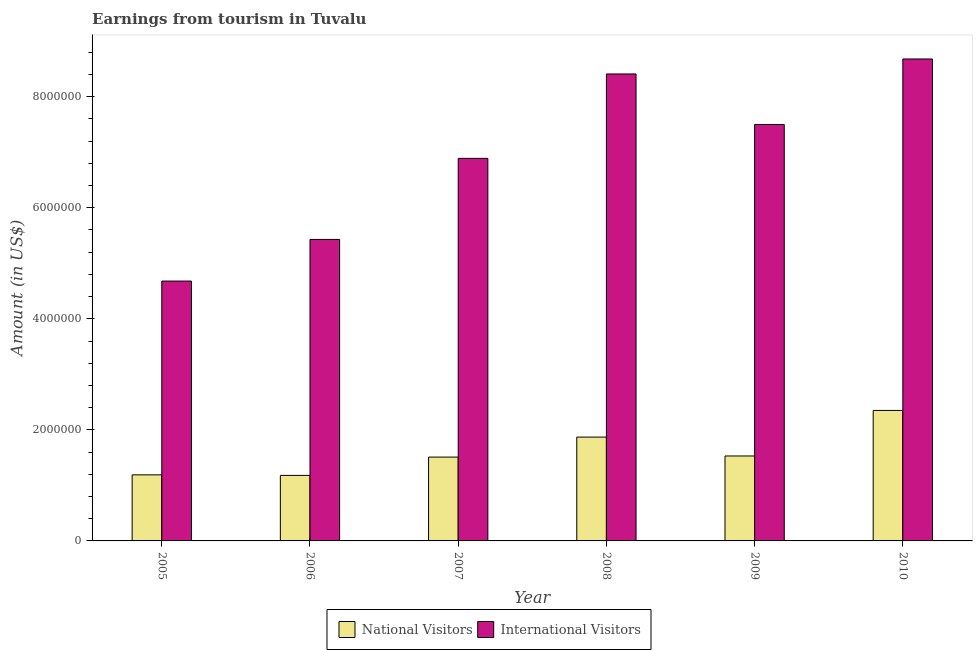Are the number of bars on each tick of the X-axis equal?
Make the answer very short. Yes. How many bars are there on the 6th tick from the left?
Provide a short and direct response. 2. What is the label of the 1st group of bars from the left?
Your answer should be compact. 2005. In how many cases, is the number of bars for a given year not equal to the number of legend labels?
Give a very brief answer. 0. What is the amount earned from national visitors in 2008?
Give a very brief answer. 1.87e+06. Across all years, what is the maximum amount earned from national visitors?
Your answer should be compact. 2.35e+06. Across all years, what is the minimum amount earned from international visitors?
Offer a terse response. 4.68e+06. In which year was the amount earned from international visitors minimum?
Offer a terse response. 2005. What is the total amount earned from national visitors in the graph?
Offer a terse response. 9.63e+06. What is the difference between the amount earned from international visitors in 2005 and that in 2010?
Offer a terse response. -4.00e+06. What is the difference between the amount earned from international visitors in 2008 and the amount earned from national visitors in 2007?
Your answer should be very brief. 1.52e+06. What is the average amount earned from national visitors per year?
Ensure brevity in your answer.  1.60e+06. In the year 2006, what is the difference between the amount earned from national visitors and amount earned from international visitors?
Make the answer very short. 0. In how many years, is the amount earned from national visitors greater than 800000 US$?
Keep it short and to the point. 6. What is the ratio of the amount earned from international visitors in 2005 to that in 2008?
Offer a terse response. 0.56. Is the difference between the amount earned from international visitors in 2008 and 2009 greater than the difference between the amount earned from national visitors in 2008 and 2009?
Keep it short and to the point. No. What is the difference between the highest and the second highest amount earned from international visitors?
Your answer should be compact. 2.70e+05. What is the difference between the highest and the lowest amount earned from international visitors?
Offer a terse response. 4.00e+06. In how many years, is the amount earned from international visitors greater than the average amount earned from international visitors taken over all years?
Ensure brevity in your answer.  3. Is the sum of the amount earned from national visitors in 2005 and 2010 greater than the maximum amount earned from international visitors across all years?
Provide a short and direct response. Yes. What does the 2nd bar from the left in 2007 represents?
Provide a short and direct response. International Visitors. What does the 1st bar from the right in 2010 represents?
Make the answer very short. International Visitors. Are all the bars in the graph horizontal?
Provide a short and direct response. No. What is the difference between two consecutive major ticks on the Y-axis?
Give a very brief answer. 2.00e+06. Are the values on the major ticks of Y-axis written in scientific E-notation?
Your answer should be very brief. No. Does the graph contain grids?
Make the answer very short. No. Where does the legend appear in the graph?
Your answer should be compact. Bottom center. What is the title of the graph?
Give a very brief answer. Earnings from tourism in Tuvalu. Does "Electricity" appear as one of the legend labels in the graph?
Offer a terse response. No. What is the label or title of the X-axis?
Offer a very short reply. Year. What is the label or title of the Y-axis?
Your answer should be compact. Amount (in US$). What is the Amount (in US$) of National Visitors in 2005?
Give a very brief answer. 1.19e+06. What is the Amount (in US$) in International Visitors in 2005?
Your response must be concise. 4.68e+06. What is the Amount (in US$) in National Visitors in 2006?
Provide a short and direct response. 1.18e+06. What is the Amount (in US$) of International Visitors in 2006?
Provide a short and direct response. 5.43e+06. What is the Amount (in US$) in National Visitors in 2007?
Your response must be concise. 1.51e+06. What is the Amount (in US$) of International Visitors in 2007?
Provide a short and direct response. 6.89e+06. What is the Amount (in US$) of National Visitors in 2008?
Offer a terse response. 1.87e+06. What is the Amount (in US$) of International Visitors in 2008?
Give a very brief answer. 8.41e+06. What is the Amount (in US$) of National Visitors in 2009?
Give a very brief answer. 1.53e+06. What is the Amount (in US$) in International Visitors in 2009?
Ensure brevity in your answer.  7.50e+06. What is the Amount (in US$) of National Visitors in 2010?
Your answer should be compact. 2.35e+06. What is the Amount (in US$) of International Visitors in 2010?
Your answer should be very brief. 8.68e+06. Across all years, what is the maximum Amount (in US$) in National Visitors?
Keep it short and to the point. 2.35e+06. Across all years, what is the maximum Amount (in US$) of International Visitors?
Offer a terse response. 8.68e+06. Across all years, what is the minimum Amount (in US$) in National Visitors?
Offer a terse response. 1.18e+06. Across all years, what is the minimum Amount (in US$) in International Visitors?
Keep it short and to the point. 4.68e+06. What is the total Amount (in US$) in National Visitors in the graph?
Ensure brevity in your answer.  9.63e+06. What is the total Amount (in US$) of International Visitors in the graph?
Ensure brevity in your answer.  4.16e+07. What is the difference between the Amount (in US$) in National Visitors in 2005 and that in 2006?
Offer a very short reply. 10000. What is the difference between the Amount (in US$) of International Visitors in 2005 and that in 2006?
Ensure brevity in your answer.  -7.50e+05. What is the difference between the Amount (in US$) in National Visitors in 2005 and that in 2007?
Offer a terse response. -3.20e+05. What is the difference between the Amount (in US$) in International Visitors in 2005 and that in 2007?
Your answer should be compact. -2.21e+06. What is the difference between the Amount (in US$) of National Visitors in 2005 and that in 2008?
Ensure brevity in your answer.  -6.80e+05. What is the difference between the Amount (in US$) of International Visitors in 2005 and that in 2008?
Make the answer very short. -3.73e+06. What is the difference between the Amount (in US$) in National Visitors in 2005 and that in 2009?
Offer a very short reply. -3.40e+05. What is the difference between the Amount (in US$) in International Visitors in 2005 and that in 2009?
Ensure brevity in your answer.  -2.82e+06. What is the difference between the Amount (in US$) in National Visitors in 2005 and that in 2010?
Provide a succinct answer. -1.16e+06. What is the difference between the Amount (in US$) of International Visitors in 2005 and that in 2010?
Offer a very short reply. -4.00e+06. What is the difference between the Amount (in US$) in National Visitors in 2006 and that in 2007?
Your response must be concise. -3.30e+05. What is the difference between the Amount (in US$) of International Visitors in 2006 and that in 2007?
Your answer should be compact. -1.46e+06. What is the difference between the Amount (in US$) of National Visitors in 2006 and that in 2008?
Offer a terse response. -6.90e+05. What is the difference between the Amount (in US$) in International Visitors in 2006 and that in 2008?
Give a very brief answer. -2.98e+06. What is the difference between the Amount (in US$) in National Visitors in 2006 and that in 2009?
Ensure brevity in your answer.  -3.50e+05. What is the difference between the Amount (in US$) of International Visitors in 2006 and that in 2009?
Offer a very short reply. -2.07e+06. What is the difference between the Amount (in US$) of National Visitors in 2006 and that in 2010?
Your answer should be compact. -1.17e+06. What is the difference between the Amount (in US$) in International Visitors in 2006 and that in 2010?
Provide a short and direct response. -3.25e+06. What is the difference between the Amount (in US$) of National Visitors in 2007 and that in 2008?
Give a very brief answer. -3.60e+05. What is the difference between the Amount (in US$) of International Visitors in 2007 and that in 2008?
Offer a very short reply. -1.52e+06. What is the difference between the Amount (in US$) in International Visitors in 2007 and that in 2009?
Provide a short and direct response. -6.10e+05. What is the difference between the Amount (in US$) of National Visitors in 2007 and that in 2010?
Your answer should be compact. -8.40e+05. What is the difference between the Amount (in US$) of International Visitors in 2007 and that in 2010?
Provide a succinct answer. -1.79e+06. What is the difference between the Amount (in US$) of National Visitors in 2008 and that in 2009?
Offer a terse response. 3.40e+05. What is the difference between the Amount (in US$) of International Visitors in 2008 and that in 2009?
Provide a succinct answer. 9.10e+05. What is the difference between the Amount (in US$) of National Visitors in 2008 and that in 2010?
Offer a very short reply. -4.80e+05. What is the difference between the Amount (in US$) of International Visitors in 2008 and that in 2010?
Offer a very short reply. -2.70e+05. What is the difference between the Amount (in US$) in National Visitors in 2009 and that in 2010?
Provide a succinct answer. -8.20e+05. What is the difference between the Amount (in US$) in International Visitors in 2009 and that in 2010?
Your answer should be very brief. -1.18e+06. What is the difference between the Amount (in US$) of National Visitors in 2005 and the Amount (in US$) of International Visitors in 2006?
Keep it short and to the point. -4.24e+06. What is the difference between the Amount (in US$) in National Visitors in 2005 and the Amount (in US$) in International Visitors in 2007?
Make the answer very short. -5.70e+06. What is the difference between the Amount (in US$) in National Visitors in 2005 and the Amount (in US$) in International Visitors in 2008?
Your answer should be very brief. -7.22e+06. What is the difference between the Amount (in US$) in National Visitors in 2005 and the Amount (in US$) in International Visitors in 2009?
Your answer should be very brief. -6.31e+06. What is the difference between the Amount (in US$) in National Visitors in 2005 and the Amount (in US$) in International Visitors in 2010?
Offer a very short reply. -7.49e+06. What is the difference between the Amount (in US$) in National Visitors in 2006 and the Amount (in US$) in International Visitors in 2007?
Make the answer very short. -5.71e+06. What is the difference between the Amount (in US$) in National Visitors in 2006 and the Amount (in US$) in International Visitors in 2008?
Offer a terse response. -7.23e+06. What is the difference between the Amount (in US$) of National Visitors in 2006 and the Amount (in US$) of International Visitors in 2009?
Offer a very short reply. -6.32e+06. What is the difference between the Amount (in US$) in National Visitors in 2006 and the Amount (in US$) in International Visitors in 2010?
Your response must be concise. -7.50e+06. What is the difference between the Amount (in US$) of National Visitors in 2007 and the Amount (in US$) of International Visitors in 2008?
Your answer should be compact. -6.90e+06. What is the difference between the Amount (in US$) in National Visitors in 2007 and the Amount (in US$) in International Visitors in 2009?
Give a very brief answer. -5.99e+06. What is the difference between the Amount (in US$) of National Visitors in 2007 and the Amount (in US$) of International Visitors in 2010?
Provide a succinct answer. -7.17e+06. What is the difference between the Amount (in US$) of National Visitors in 2008 and the Amount (in US$) of International Visitors in 2009?
Keep it short and to the point. -5.63e+06. What is the difference between the Amount (in US$) of National Visitors in 2008 and the Amount (in US$) of International Visitors in 2010?
Offer a terse response. -6.81e+06. What is the difference between the Amount (in US$) in National Visitors in 2009 and the Amount (in US$) in International Visitors in 2010?
Keep it short and to the point. -7.15e+06. What is the average Amount (in US$) of National Visitors per year?
Ensure brevity in your answer.  1.60e+06. What is the average Amount (in US$) in International Visitors per year?
Your response must be concise. 6.93e+06. In the year 2005, what is the difference between the Amount (in US$) of National Visitors and Amount (in US$) of International Visitors?
Your answer should be compact. -3.49e+06. In the year 2006, what is the difference between the Amount (in US$) in National Visitors and Amount (in US$) in International Visitors?
Ensure brevity in your answer.  -4.25e+06. In the year 2007, what is the difference between the Amount (in US$) of National Visitors and Amount (in US$) of International Visitors?
Offer a terse response. -5.38e+06. In the year 2008, what is the difference between the Amount (in US$) of National Visitors and Amount (in US$) of International Visitors?
Ensure brevity in your answer.  -6.54e+06. In the year 2009, what is the difference between the Amount (in US$) of National Visitors and Amount (in US$) of International Visitors?
Your response must be concise. -5.97e+06. In the year 2010, what is the difference between the Amount (in US$) of National Visitors and Amount (in US$) of International Visitors?
Your response must be concise. -6.33e+06. What is the ratio of the Amount (in US$) in National Visitors in 2005 to that in 2006?
Your answer should be compact. 1.01. What is the ratio of the Amount (in US$) of International Visitors in 2005 to that in 2006?
Make the answer very short. 0.86. What is the ratio of the Amount (in US$) of National Visitors in 2005 to that in 2007?
Ensure brevity in your answer.  0.79. What is the ratio of the Amount (in US$) of International Visitors in 2005 to that in 2007?
Ensure brevity in your answer.  0.68. What is the ratio of the Amount (in US$) in National Visitors in 2005 to that in 2008?
Your answer should be compact. 0.64. What is the ratio of the Amount (in US$) of International Visitors in 2005 to that in 2008?
Ensure brevity in your answer.  0.56. What is the ratio of the Amount (in US$) in National Visitors in 2005 to that in 2009?
Your answer should be very brief. 0.78. What is the ratio of the Amount (in US$) in International Visitors in 2005 to that in 2009?
Keep it short and to the point. 0.62. What is the ratio of the Amount (in US$) of National Visitors in 2005 to that in 2010?
Make the answer very short. 0.51. What is the ratio of the Amount (in US$) of International Visitors in 2005 to that in 2010?
Your answer should be compact. 0.54. What is the ratio of the Amount (in US$) in National Visitors in 2006 to that in 2007?
Provide a succinct answer. 0.78. What is the ratio of the Amount (in US$) of International Visitors in 2006 to that in 2007?
Ensure brevity in your answer.  0.79. What is the ratio of the Amount (in US$) in National Visitors in 2006 to that in 2008?
Keep it short and to the point. 0.63. What is the ratio of the Amount (in US$) of International Visitors in 2006 to that in 2008?
Provide a short and direct response. 0.65. What is the ratio of the Amount (in US$) of National Visitors in 2006 to that in 2009?
Your response must be concise. 0.77. What is the ratio of the Amount (in US$) in International Visitors in 2006 to that in 2009?
Offer a very short reply. 0.72. What is the ratio of the Amount (in US$) in National Visitors in 2006 to that in 2010?
Your answer should be compact. 0.5. What is the ratio of the Amount (in US$) of International Visitors in 2006 to that in 2010?
Your answer should be very brief. 0.63. What is the ratio of the Amount (in US$) in National Visitors in 2007 to that in 2008?
Make the answer very short. 0.81. What is the ratio of the Amount (in US$) in International Visitors in 2007 to that in 2008?
Your response must be concise. 0.82. What is the ratio of the Amount (in US$) in National Visitors in 2007 to that in 2009?
Offer a terse response. 0.99. What is the ratio of the Amount (in US$) in International Visitors in 2007 to that in 2009?
Provide a short and direct response. 0.92. What is the ratio of the Amount (in US$) in National Visitors in 2007 to that in 2010?
Keep it short and to the point. 0.64. What is the ratio of the Amount (in US$) of International Visitors in 2007 to that in 2010?
Your answer should be very brief. 0.79. What is the ratio of the Amount (in US$) of National Visitors in 2008 to that in 2009?
Ensure brevity in your answer.  1.22. What is the ratio of the Amount (in US$) of International Visitors in 2008 to that in 2009?
Keep it short and to the point. 1.12. What is the ratio of the Amount (in US$) of National Visitors in 2008 to that in 2010?
Keep it short and to the point. 0.8. What is the ratio of the Amount (in US$) of International Visitors in 2008 to that in 2010?
Your answer should be very brief. 0.97. What is the ratio of the Amount (in US$) of National Visitors in 2009 to that in 2010?
Give a very brief answer. 0.65. What is the ratio of the Amount (in US$) of International Visitors in 2009 to that in 2010?
Make the answer very short. 0.86. What is the difference between the highest and the lowest Amount (in US$) of National Visitors?
Provide a short and direct response. 1.17e+06. What is the difference between the highest and the lowest Amount (in US$) in International Visitors?
Ensure brevity in your answer.  4.00e+06. 